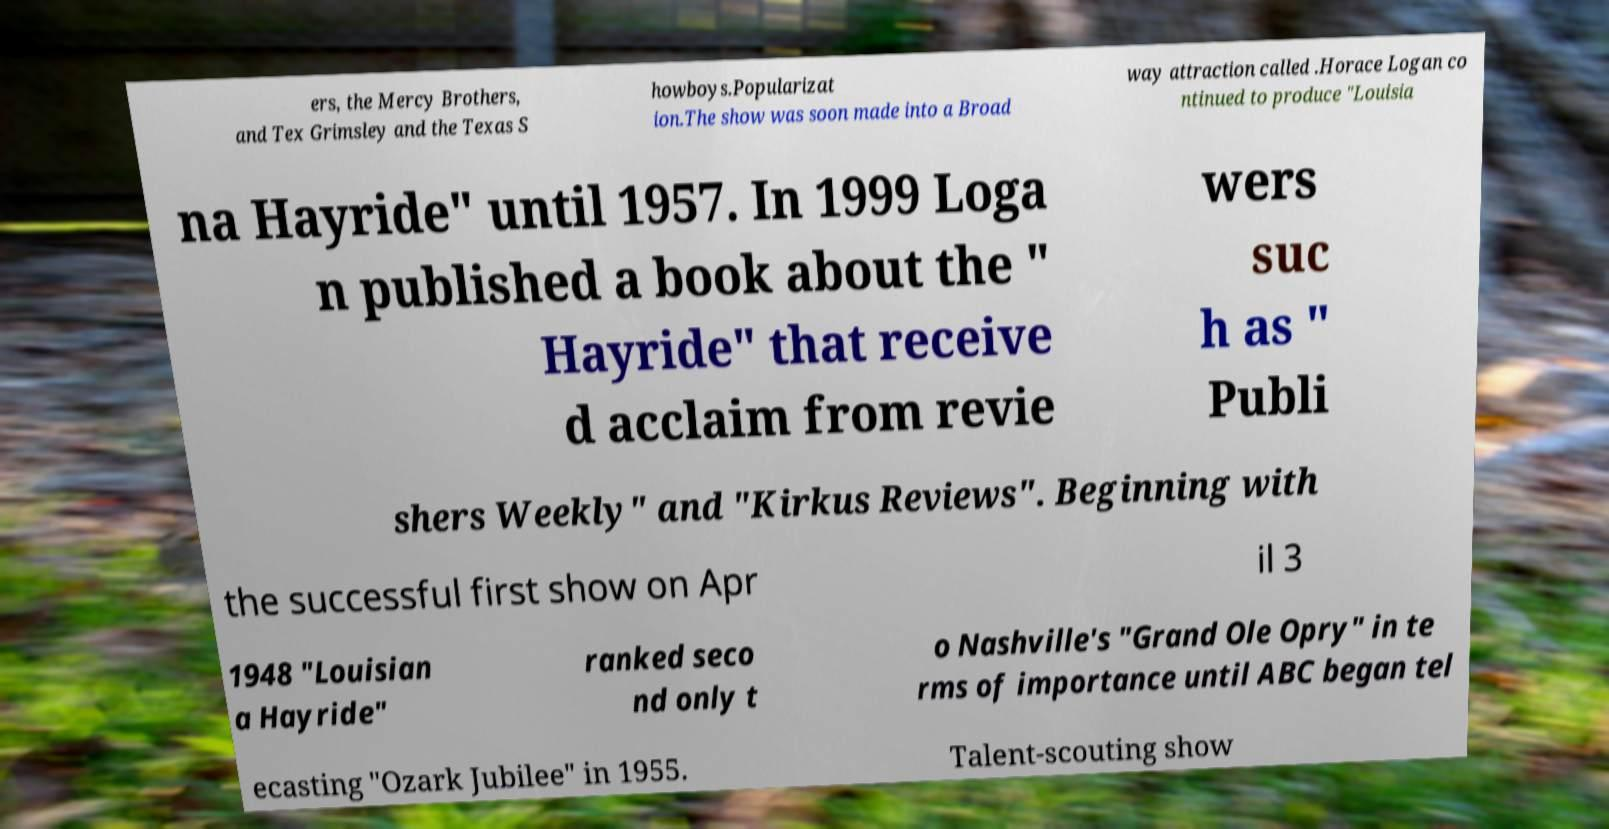What messages or text are displayed in this image? I need them in a readable, typed format. ers, the Mercy Brothers, and Tex Grimsley and the Texas S howboys.Popularizat ion.The show was soon made into a Broad way attraction called .Horace Logan co ntinued to produce "Louisia na Hayride" until 1957. In 1999 Loga n published a book about the " Hayride" that receive d acclaim from revie wers suc h as " Publi shers Weekly" and "Kirkus Reviews". Beginning with the successful first show on Apr il 3 1948 "Louisian a Hayride" ranked seco nd only t o Nashville's "Grand Ole Opry" in te rms of importance until ABC began tel ecasting "Ozark Jubilee" in 1955. Talent-scouting show 